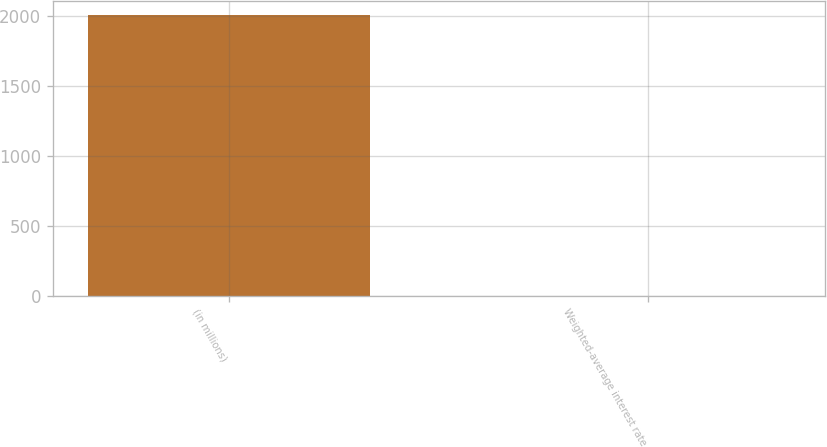<chart> <loc_0><loc_0><loc_500><loc_500><bar_chart><fcel>(in millions)<fcel>Weighted-average interest rate<nl><fcel>2010<fcel>0.39<nl></chart> 